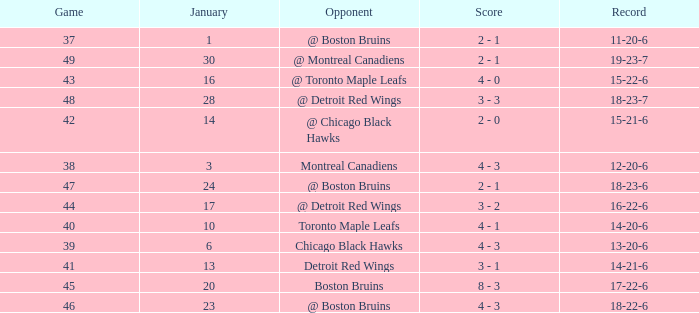Help me parse the entirety of this table. {'header': ['Game', 'January', 'Opponent', 'Score', 'Record'], 'rows': [['37', '1', '@ Boston Bruins', '2 - 1', '11-20-6'], ['49', '30', '@ Montreal Canadiens', '2 - 1', '19-23-7'], ['43', '16', '@ Toronto Maple Leafs', '4 - 0', '15-22-6'], ['48', '28', '@ Detroit Red Wings', '3 - 3', '18-23-7'], ['42', '14', '@ Chicago Black Hawks', '2 - 0', '15-21-6'], ['38', '3', 'Montreal Canadiens', '4 - 3', '12-20-6'], ['47', '24', '@ Boston Bruins', '2 - 1', '18-23-6'], ['44', '17', '@ Detroit Red Wings', '3 - 2', '16-22-6'], ['40', '10', 'Toronto Maple Leafs', '4 - 1', '14-20-6'], ['39', '6', 'Chicago Black Hawks', '4 - 3', '13-20-6'], ['41', '13', 'Detroit Red Wings', '3 - 1', '14-21-6'], ['45', '20', 'Boston Bruins', '8 - 3', '17-22-6'], ['46', '23', '@ Boston Bruins', '4 - 3', '18-22-6']]} Who was the opponent with the record of 15-21-6? @ Chicago Black Hawks. 